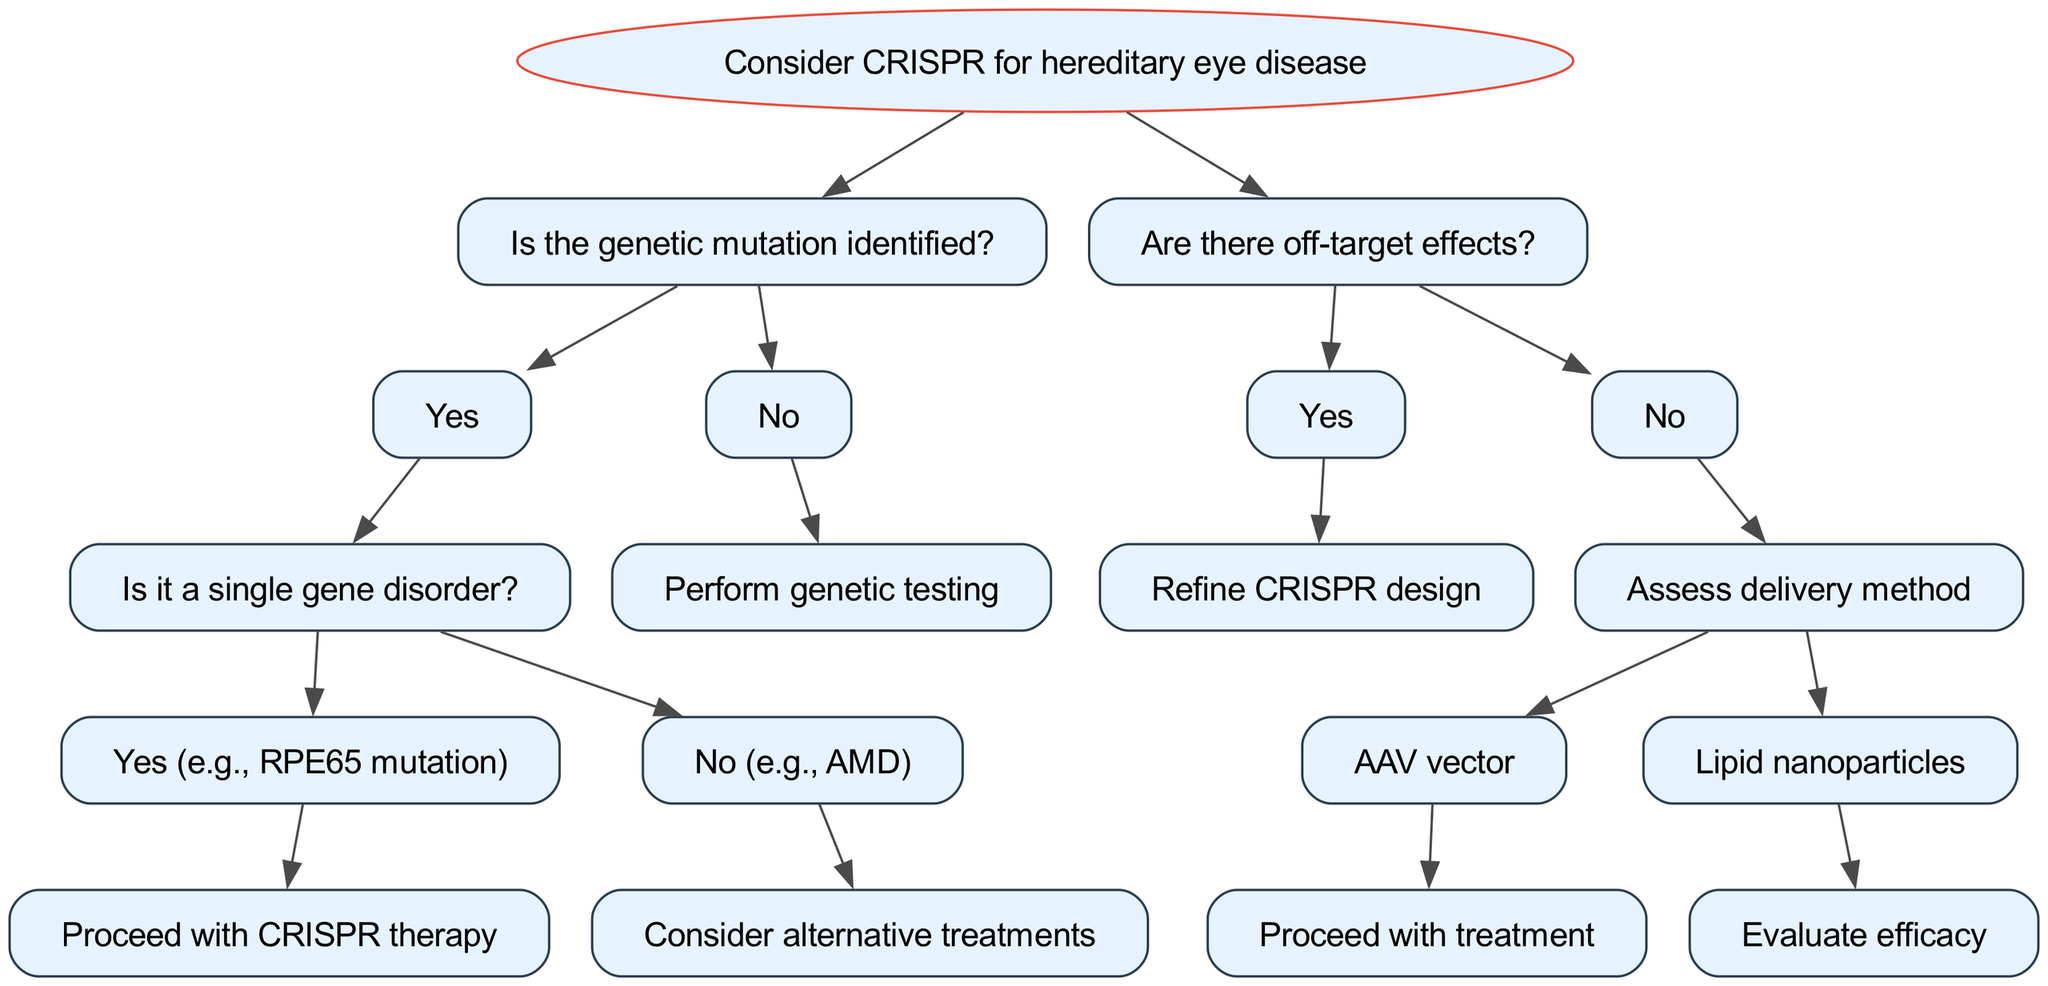What is the root node of the decision tree? The diagram clearly states the root node as "Consider CRISPR for hereditary eye disease." This is the starting point and main question of the decision-making process presented in the tree.
Answer: Consider CRISPR for hereditary eye disease How many nodes are directly under the root node? From the diagram, there are two nodes directly under the root node: "Is the genetic mutation identified?" and "Are there off-target effects?". This count confirms that the decision-making process branches from these two main queries.
Answer: 2 What is the outcome if no genetic mutation is identified? Following the decision tree, if no genetic mutation is identified, the next action is to "Perform genetic testing." This indicates that genetic identification is crucial before proceeding with any treatment options.
Answer: Perform genetic testing If the genetic mutation is identified as a single gene disorder, what is the next step? The decision tree indicates that if the mutation is a single gene disorder (e.g., RPE65 mutation), the subsequent action is to "Proceed with CRISPR therapy." This shows that specific types of disorders are deemed appropriate for CRISPR application.
Answer: Proceed with CRISPR therapy What should be done if there are off-target effects? According to the diagram, if off-target effects are present, the response is to "Refine CRISPR design." This emphasizes the need for precision in CRISPR applications to minimize unintended genetic alterations.
Answer: Refine CRISPR design What delivery method is associated with proceeding to treatment when there are no off-target effects? The diagram specifies that if there are no off-target effects, the next step involves "Assess delivery method," which further branches into either "AAV vector" or "Lipid nanoparticles." If AAV vector is chosen, the treatment can proceed.
Answer: AAV vector Which alternative is suggested for multi-gene disorders such as AMD? The decision tree indicates that if the genetic condition is a multi-gene disorder (e.g., AMD), the recommendation is to "Consider alternative treatments." This indicates that CRISPR may not be suitable for more complex genetic disorders.
Answer: Consider alternative treatments What evaluation is suggested for lipid nanoparticles? If lipid nanoparticles are chosen as the delivery method, the next step according to the decision tree is to "Evaluate efficacy." This step is necessary to assess how effective this delivery mechanism may be in administering the CRISPR therapy.
Answer: Evaluate efficacy 